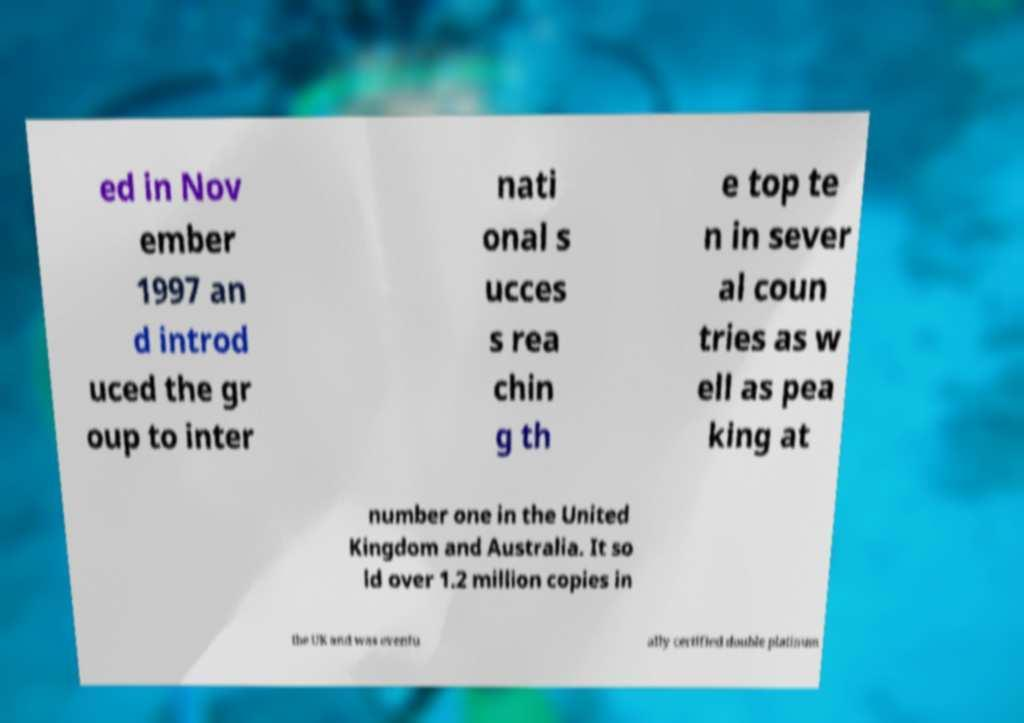Could you extract and type out the text from this image? ed in Nov ember 1997 an d introd uced the gr oup to inter nati onal s ucces s rea chin g th e top te n in sever al coun tries as w ell as pea king at number one in the United Kingdom and Australia. It so ld over 1.2 million copies in the UK and was eventu ally certified double platinum 